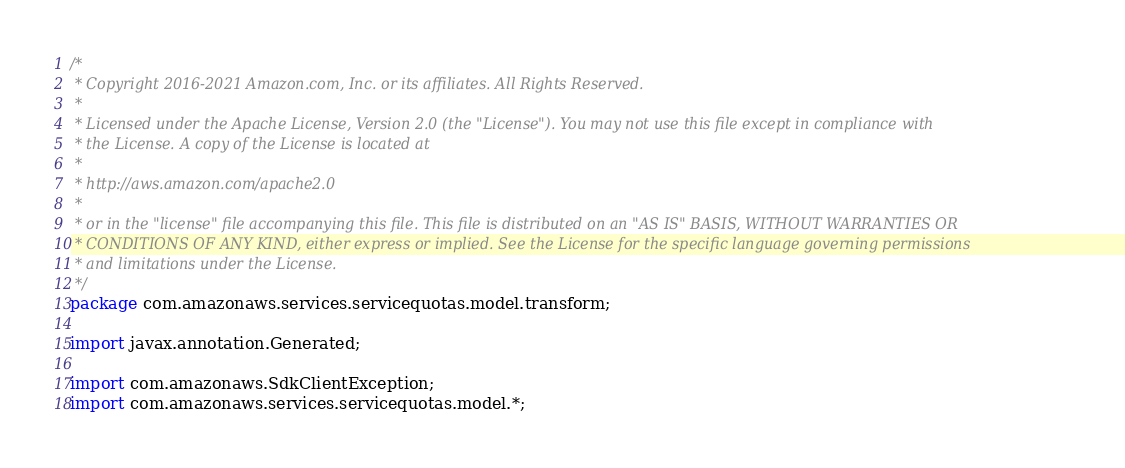Convert code to text. <code><loc_0><loc_0><loc_500><loc_500><_Java_>/*
 * Copyright 2016-2021 Amazon.com, Inc. or its affiliates. All Rights Reserved.
 * 
 * Licensed under the Apache License, Version 2.0 (the "License"). You may not use this file except in compliance with
 * the License. A copy of the License is located at
 * 
 * http://aws.amazon.com/apache2.0
 * 
 * or in the "license" file accompanying this file. This file is distributed on an "AS IS" BASIS, WITHOUT WARRANTIES OR
 * CONDITIONS OF ANY KIND, either express or implied. See the License for the specific language governing permissions
 * and limitations under the License.
 */
package com.amazonaws.services.servicequotas.model.transform;

import javax.annotation.Generated;

import com.amazonaws.SdkClientException;
import com.amazonaws.services.servicequotas.model.*;
</code> 